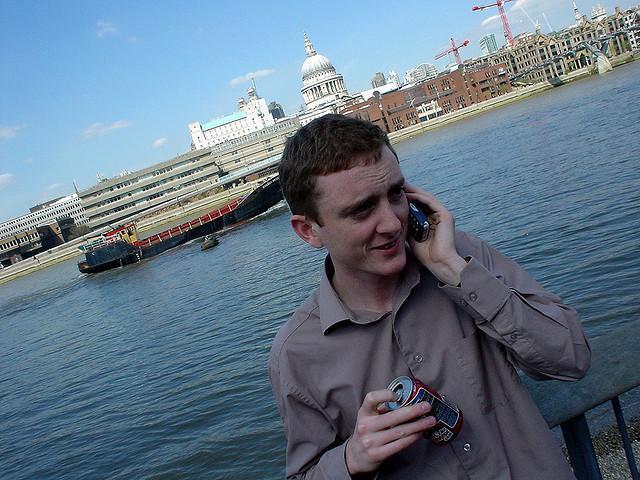Is this affirmation: "The person is far from the boat." correct?
Answer yes or no. Yes. 